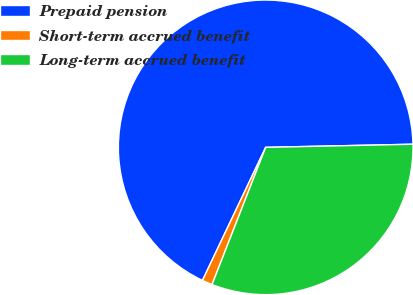<chart> <loc_0><loc_0><loc_500><loc_500><pie_chart><fcel>Prepaid pension<fcel>Short-term accrued benefit<fcel>Long-term accrued benefit<nl><fcel>67.61%<fcel>1.13%<fcel>31.27%<nl></chart> 